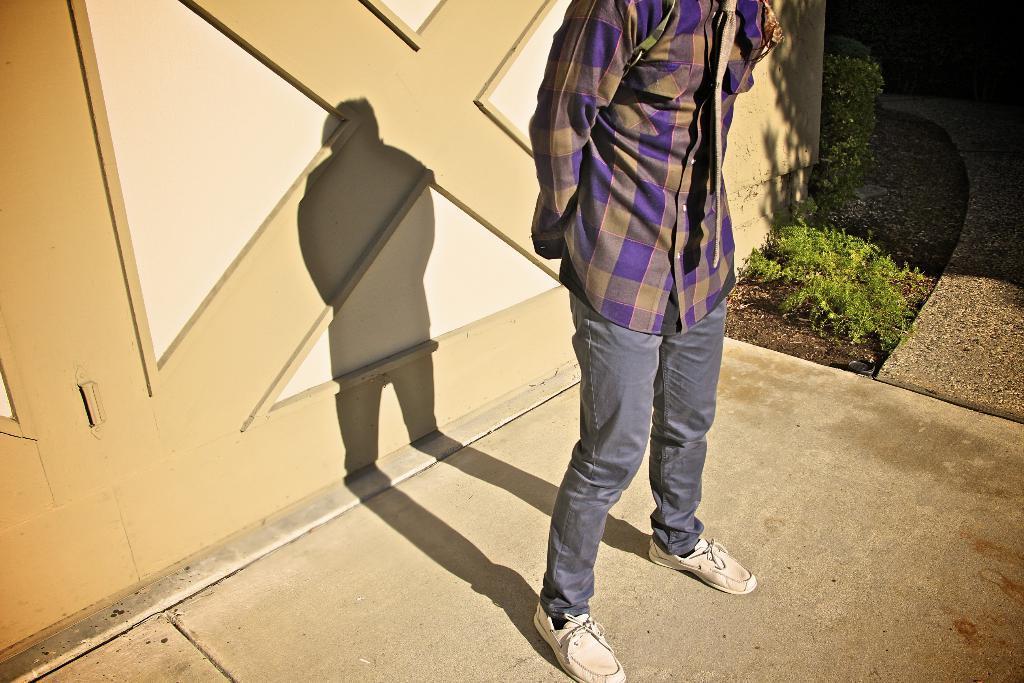In one or two sentences, can you explain what this image depicts? A person is standing. Here we can see a person shadow and plants. 